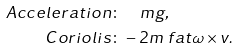Convert formula to latex. <formula><loc_0><loc_0><loc_500><loc_500>A c c e l e r a t i o n \colon & { \quad } m { g } , \\ C o r i o l i s \colon & - 2 m \ f a t { \omega } \times { v } .</formula> 